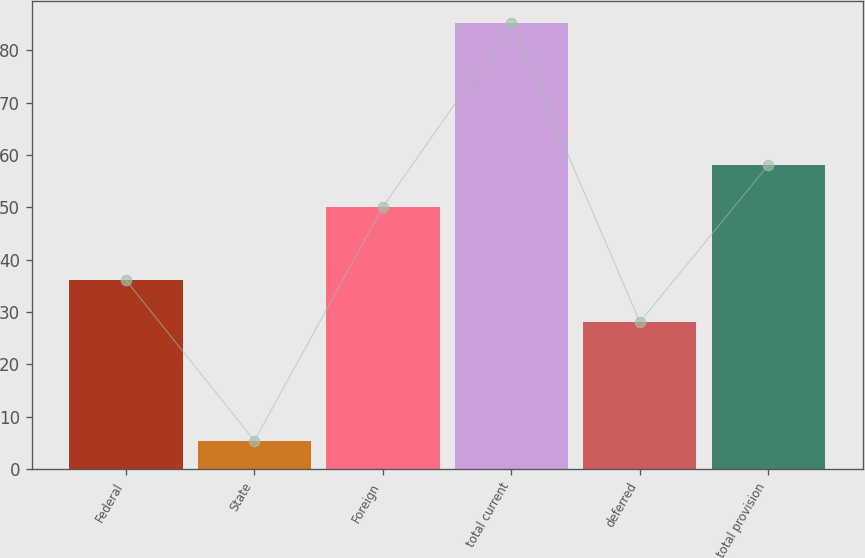Convert chart to OTSL. <chart><loc_0><loc_0><loc_500><loc_500><bar_chart><fcel>Federal<fcel>State<fcel>Foreign<fcel>total current<fcel>deferred<fcel>total provision<nl><fcel>36.08<fcel>5.4<fcel>50.1<fcel>85.2<fcel>28.1<fcel>58.08<nl></chart> 